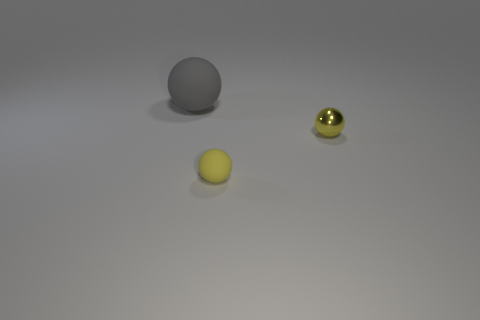The object that is the same size as the metal sphere is what color?
Your response must be concise. Yellow. Are there any big red rubber objects of the same shape as the metallic thing?
Make the answer very short. No. What material is the small object to the left of the small yellow object behind the thing that is in front of the tiny metal thing made of?
Provide a succinct answer. Rubber. How many other objects are the same size as the gray matte sphere?
Make the answer very short. 0. The tiny matte thing has what color?
Keep it short and to the point. Yellow. How many metallic things are either big purple balls or yellow objects?
Make the answer very short. 1. There is a thing on the left side of the tiny yellow thing on the left side of the sphere that is to the right of the small rubber ball; how big is it?
Your response must be concise. Large. What is the size of the thing that is both to the right of the gray thing and on the left side of the yellow shiny thing?
Give a very brief answer. Small. There is a matte object that is right of the gray rubber sphere; does it have the same color as the tiny thing behind the yellow matte sphere?
Give a very brief answer. Yes. There is a metallic sphere; how many tiny yellow matte balls are in front of it?
Provide a short and direct response. 1. 